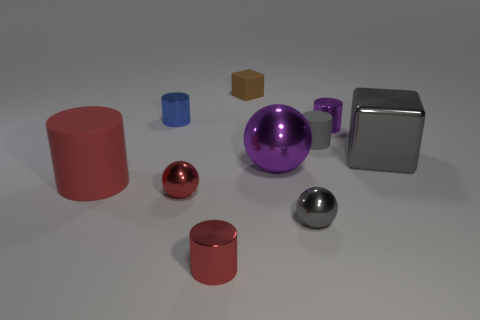Subtract all large red cylinders. How many cylinders are left? 4 Subtract all gray cylinders. How many cylinders are left? 4 Subtract all purple cylinders. Subtract all purple cubes. How many cylinders are left? 4 Subtract 1 gray cylinders. How many objects are left? 9 Subtract all balls. How many objects are left? 7 Subtract all big balls. Subtract all purple cylinders. How many objects are left? 8 Add 1 purple objects. How many purple objects are left? 3 Add 8 big purple shiny objects. How many big purple shiny objects exist? 9 